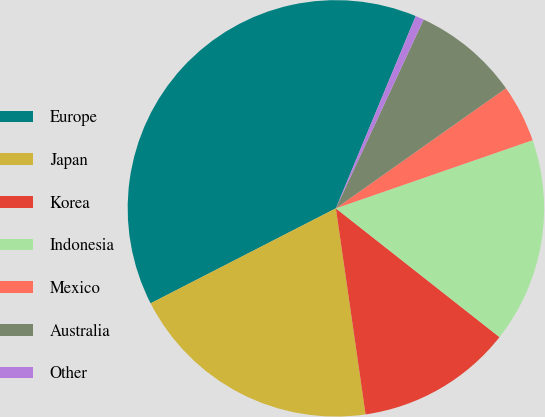<chart> <loc_0><loc_0><loc_500><loc_500><pie_chart><fcel>Europe<fcel>Japan<fcel>Korea<fcel>Indonesia<fcel>Mexico<fcel>Australia<fcel>Other<nl><fcel>38.81%<fcel>19.74%<fcel>12.11%<fcel>15.92%<fcel>4.48%<fcel>8.29%<fcel>0.66%<nl></chart> 